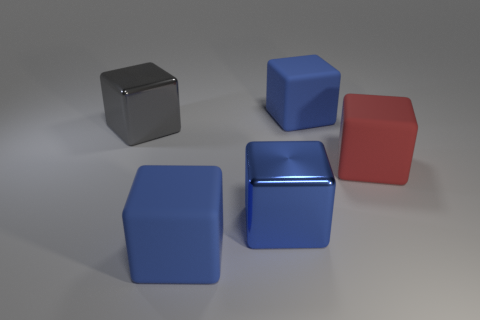There is a shiny object that is on the right side of the big gray metal thing; is its color the same as the big rubber cube behind the gray block?
Provide a succinct answer. Yes. Is there a block that has the same material as the large gray thing?
Offer a very short reply. Yes. Does the big red object have the same material as the large gray block?
Offer a very short reply. No. There is a large metallic object in front of the big gray metallic thing; what number of blocks are behind it?
Your answer should be compact. 3. What number of blue objects are large matte blocks or metal cubes?
Your answer should be compact. 3. There is a large shiny thing in front of the big object right of the large matte object that is behind the red rubber thing; what shape is it?
Provide a short and direct response. Cube. What is the color of the shiny cube that is the same size as the blue shiny thing?
Provide a succinct answer. Gray. How many other gray things have the same shape as the gray thing?
Your answer should be very brief. 0. There is a gray block; is its size the same as the rubber block in front of the big red object?
Your answer should be very brief. Yes. What is the shape of the blue thing behind the shiny block that is in front of the gray object?
Your answer should be compact. Cube. 